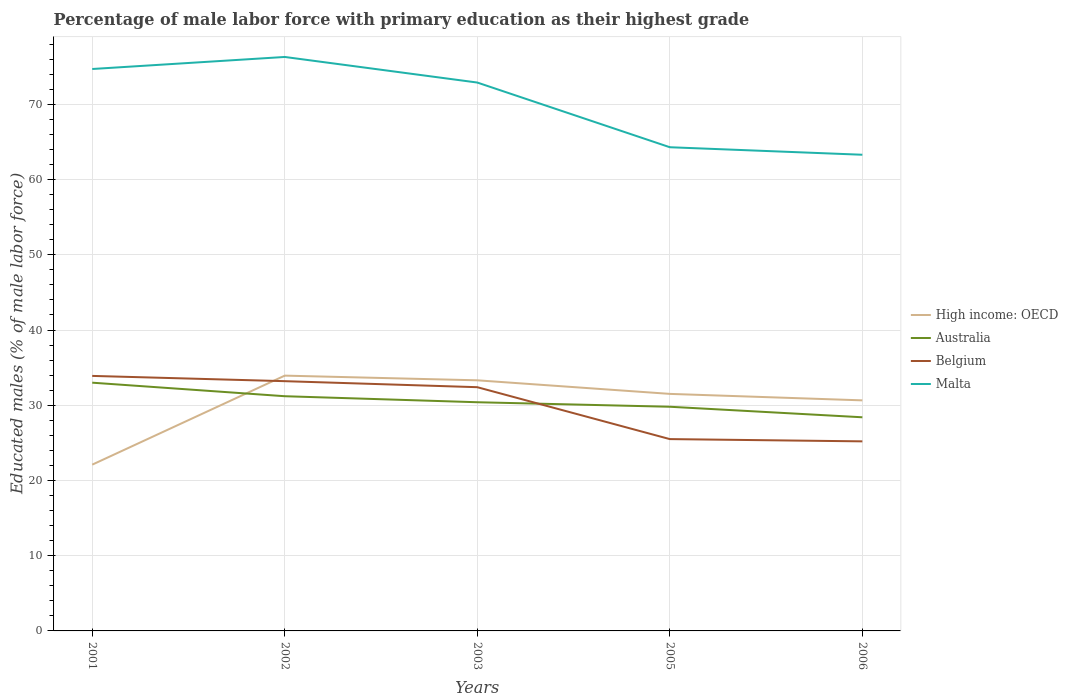Does the line corresponding to Belgium intersect with the line corresponding to Malta?
Offer a very short reply. No. Is the number of lines equal to the number of legend labels?
Make the answer very short. Yes. Across all years, what is the maximum percentage of male labor force with primary education in High income: OECD?
Keep it short and to the point. 22.1. In which year was the percentage of male labor force with primary education in High income: OECD maximum?
Make the answer very short. 2001. What is the difference between the highest and the second highest percentage of male labor force with primary education in Belgium?
Your answer should be compact. 8.7. Is the percentage of male labor force with primary education in High income: OECD strictly greater than the percentage of male labor force with primary education in Belgium over the years?
Offer a very short reply. No. Does the graph contain grids?
Make the answer very short. Yes. How are the legend labels stacked?
Your answer should be very brief. Vertical. What is the title of the graph?
Your answer should be very brief. Percentage of male labor force with primary education as their highest grade. What is the label or title of the Y-axis?
Offer a very short reply. Educated males (% of male labor force). What is the Educated males (% of male labor force) of High income: OECD in 2001?
Give a very brief answer. 22.1. What is the Educated males (% of male labor force) of Belgium in 2001?
Your response must be concise. 33.9. What is the Educated males (% of male labor force) in Malta in 2001?
Give a very brief answer. 74.7. What is the Educated males (% of male labor force) in High income: OECD in 2002?
Make the answer very short. 33.94. What is the Educated males (% of male labor force) in Australia in 2002?
Offer a very short reply. 31.2. What is the Educated males (% of male labor force) in Belgium in 2002?
Provide a short and direct response. 33.2. What is the Educated males (% of male labor force) of Malta in 2002?
Ensure brevity in your answer.  76.3. What is the Educated males (% of male labor force) in High income: OECD in 2003?
Your answer should be very brief. 33.31. What is the Educated males (% of male labor force) in Australia in 2003?
Your answer should be compact. 30.4. What is the Educated males (% of male labor force) of Belgium in 2003?
Your answer should be very brief. 32.4. What is the Educated males (% of male labor force) in Malta in 2003?
Your response must be concise. 72.9. What is the Educated males (% of male labor force) of High income: OECD in 2005?
Keep it short and to the point. 31.51. What is the Educated males (% of male labor force) in Australia in 2005?
Keep it short and to the point. 29.8. What is the Educated males (% of male labor force) of Belgium in 2005?
Keep it short and to the point. 25.5. What is the Educated males (% of male labor force) of Malta in 2005?
Offer a very short reply. 64.3. What is the Educated males (% of male labor force) of High income: OECD in 2006?
Provide a succinct answer. 30.65. What is the Educated males (% of male labor force) in Australia in 2006?
Keep it short and to the point. 28.4. What is the Educated males (% of male labor force) in Belgium in 2006?
Keep it short and to the point. 25.2. What is the Educated males (% of male labor force) of Malta in 2006?
Offer a terse response. 63.3. Across all years, what is the maximum Educated males (% of male labor force) in High income: OECD?
Ensure brevity in your answer.  33.94. Across all years, what is the maximum Educated males (% of male labor force) of Australia?
Give a very brief answer. 33. Across all years, what is the maximum Educated males (% of male labor force) in Belgium?
Your answer should be compact. 33.9. Across all years, what is the maximum Educated males (% of male labor force) in Malta?
Give a very brief answer. 76.3. Across all years, what is the minimum Educated males (% of male labor force) in High income: OECD?
Keep it short and to the point. 22.1. Across all years, what is the minimum Educated males (% of male labor force) of Australia?
Offer a very short reply. 28.4. Across all years, what is the minimum Educated males (% of male labor force) in Belgium?
Offer a terse response. 25.2. Across all years, what is the minimum Educated males (% of male labor force) in Malta?
Ensure brevity in your answer.  63.3. What is the total Educated males (% of male labor force) of High income: OECD in the graph?
Make the answer very short. 151.52. What is the total Educated males (% of male labor force) of Australia in the graph?
Give a very brief answer. 152.8. What is the total Educated males (% of male labor force) in Belgium in the graph?
Provide a short and direct response. 150.2. What is the total Educated males (% of male labor force) in Malta in the graph?
Your response must be concise. 351.5. What is the difference between the Educated males (% of male labor force) of High income: OECD in 2001 and that in 2002?
Offer a very short reply. -11.83. What is the difference between the Educated males (% of male labor force) of Australia in 2001 and that in 2002?
Your answer should be compact. 1.8. What is the difference between the Educated males (% of male labor force) in Malta in 2001 and that in 2002?
Make the answer very short. -1.6. What is the difference between the Educated males (% of male labor force) of High income: OECD in 2001 and that in 2003?
Ensure brevity in your answer.  -11.21. What is the difference between the Educated males (% of male labor force) of Australia in 2001 and that in 2003?
Provide a short and direct response. 2.6. What is the difference between the Educated males (% of male labor force) of High income: OECD in 2001 and that in 2005?
Make the answer very short. -9.41. What is the difference between the Educated males (% of male labor force) of Australia in 2001 and that in 2005?
Your answer should be compact. 3.2. What is the difference between the Educated males (% of male labor force) in High income: OECD in 2001 and that in 2006?
Give a very brief answer. -8.55. What is the difference between the Educated males (% of male labor force) of Australia in 2001 and that in 2006?
Your answer should be compact. 4.6. What is the difference between the Educated males (% of male labor force) in Belgium in 2001 and that in 2006?
Ensure brevity in your answer.  8.7. What is the difference between the Educated males (% of male labor force) in High income: OECD in 2002 and that in 2003?
Your answer should be compact. 0.62. What is the difference between the Educated males (% of male labor force) of High income: OECD in 2002 and that in 2005?
Offer a terse response. 2.43. What is the difference between the Educated males (% of male labor force) of Australia in 2002 and that in 2005?
Provide a succinct answer. 1.4. What is the difference between the Educated males (% of male labor force) in Malta in 2002 and that in 2005?
Offer a very short reply. 12. What is the difference between the Educated males (% of male labor force) of High income: OECD in 2002 and that in 2006?
Give a very brief answer. 3.29. What is the difference between the Educated males (% of male labor force) in Malta in 2002 and that in 2006?
Keep it short and to the point. 13. What is the difference between the Educated males (% of male labor force) of High income: OECD in 2003 and that in 2005?
Ensure brevity in your answer.  1.8. What is the difference between the Educated males (% of male labor force) in Australia in 2003 and that in 2005?
Your answer should be very brief. 0.6. What is the difference between the Educated males (% of male labor force) in Belgium in 2003 and that in 2005?
Provide a succinct answer. 6.9. What is the difference between the Educated males (% of male labor force) of Malta in 2003 and that in 2005?
Provide a succinct answer. 8.6. What is the difference between the Educated males (% of male labor force) of High income: OECD in 2003 and that in 2006?
Provide a short and direct response. 2.66. What is the difference between the Educated males (% of male labor force) in Australia in 2003 and that in 2006?
Provide a short and direct response. 2. What is the difference between the Educated males (% of male labor force) of Malta in 2003 and that in 2006?
Make the answer very short. 9.6. What is the difference between the Educated males (% of male labor force) of High income: OECD in 2005 and that in 2006?
Your response must be concise. 0.86. What is the difference between the Educated males (% of male labor force) in Belgium in 2005 and that in 2006?
Your response must be concise. 0.3. What is the difference between the Educated males (% of male labor force) of High income: OECD in 2001 and the Educated males (% of male labor force) of Australia in 2002?
Provide a short and direct response. -9.1. What is the difference between the Educated males (% of male labor force) of High income: OECD in 2001 and the Educated males (% of male labor force) of Belgium in 2002?
Make the answer very short. -11.1. What is the difference between the Educated males (% of male labor force) of High income: OECD in 2001 and the Educated males (% of male labor force) of Malta in 2002?
Keep it short and to the point. -54.2. What is the difference between the Educated males (% of male labor force) in Australia in 2001 and the Educated males (% of male labor force) in Malta in 2002?
Provide a succinct answer. -43.3. What is the difference between the Educated males (% of male labor force) of Belgium in 2001 and the Educated males (% of male labor force) of Malta in 2002?
Provide a succinct answer. -42.4. What is the difference between the Educated males (% of male labor force) in High income: OECD in 2001 and the Educated males (% of male labor force) in Australia in 2003?
Ensure brevity in your answer.  -8.3. What is the difference between the Educated males (% of male labor force) in High income: OECD in 2001 and the Educated males (% of male labor force) in Belgium in 2003?
Make the answer very short. -10.3. What is the difference between the Educated males (% of male labor force) of High income: OECD in 2001 and the Educated males (% of male labor force) of Malta in 2003?
Make the answer very short. -50.8. What is the difference between the Educated males (% of male labor force) in Australia in 2001 and the Educated males (% of male labor force) in Malta in 2003?
Offer a very short reply. -39.9. What is the difference between the Educated males (% of male labor force) in Belgium in 2001 and the Educated males (% of male labor force) in Malta in 2003?
Keep it short and to the point. -39. What is the difference between the Educated males (% of male labor force) in High income: OECD in 2001 and the Educated males (% of male labor force) in Australia in 2005?
Your answer should be very brief. -7.7. What is the difference between the Educated males (% of male labor force) in High income: OECD in 2001 and the Educated males (% of male labor force) in Belgium in 2005?
Provide a succinct answer. -3.4. What is the difference between the Educated males (% of male labor force) of High income: OECD in 2001 and the Educated males (% of male labor force) of Malta in 2005?
Provide a succinct answer. -42.2. What is the difference between the Educated males (% of male labor force) of Australia in 2001 and the Educated males (% of male labor force) of Belgium in 2005?
Keep it short and to the point. 7.5. What is the difference between the Educated males (% of male labor force) in Australia in 2001 and the Educated males (% of male labor force) in Malta in 2005?
Make the answer very short. -31.3. What is the difference between the Educated males (% of male labor force) in Belgium in 2001 and the Educated males (% of male labor force) in Malta in 2005?
Keep it short and to the point. -30.4. What is the difference between the Educated males (% of male labor force) in High income: OECD in 2001 and the Educated males (% of male labor force) in Australia in 2006?
Provide a succinct answer. -6.3. What is the difference between the Educated males (% of male labor force) of High income: OECD in 2001 and the Educated males (% of male labor force) of Belgium in 2006?
Keep it short and to the point. -3.1. What is the difference between the Educated males (% of male labor force) of High income: OECD in 2001 and the Educated males (% of male labor force) of Malta in 2006?
Your answer should be very brief. -41.2. What is the difference between the Educated males (% of male labor force) of Australia in 2001 and the Educated males (% of male labor force) of Belgium in 2006?
Ensure brevity in your answer.  7.8. What is the difference between the Educated males (% of male labor force) in Australia in 2001 and the Educated males (% of male labor force) in Malta in 2006?
Your response must be concise. -30.3. What is the difference between the Educated males (% of male labor force) of Belgium in 2001 and the Educated males (% of male labor force) of Malta in 2006?
Make the answer very short. -29.4. What is the difference between the Educated males (% of male labor force) of High income: OECD in 2002 and the Educated males (% of male labor force) of Australia in 2003?
Make the answer very short. 3.54. What is the difference between the Educated males (% of male labor force) of High income: OECD in 2002 and the Educated males (% of male labor force) of Belgium in 2003?
Keep it short and to the point. 1.54. What is the difference between the Educated males (% of male labor force) in High income: OECD in 2002 and the Educated males (% of male labor force) in Malta in 2003?
Keep it short and to the point. -38.96. What is the difference between the Educated males (% of male labor force) of Australia in 2002 and the Educated males (% of male labor force) of Belgium in 2003?
Make the answer very short. -1.2. What is the difference between the Educated males (% of male labor force) in Australia in 2002 and the Educated males (% of male labor force) in Malta in 2003?
Your response must be concise. -41.7. What is the difference between the Educated males (% of male labor force) in Belgium in 2002 and the Educated males (% of male labor force) in Malta in 2003?
Your answer should be very brief. -39.7. What is the difference between the Educated males (% of male labor force) of High income: OECD in 2002 and the Educated males (% of male labor force) of Australia in 2005?
Provide a succinct answer. 4.14. What is the difference between the Educated males (% of male labor force) of High income: OECD in 2002 and the Educated males (% of male labor force) of Belgium in 2005?
Your answer should be compact. 8.44. What is the difference between the Educated males (% of male labor force) of High income: OECD in 2002 and the Educated males (% of male labor force) of Malta in 2005?
Your response must be concise. -30.36. What is the difference between the Educated males (% of male labor force) in Australia in 2002 and the Educated males (% of male labor force) in Malta in 2005?
Provide a short and direct response. -33.1. What is the difference between the Educated males (% of male labor force) in Belgium in 2002 and the Educated males (% of male labor force) in Malta in 2005?
Your answer should be very brief. -31.1. What is the difference between the Educated males (% of male labor force) of High income: OECD in 2002 and the Educated males (% of male labor force) of Australia in 2006?
Your response must be concise. 5.54. What is the difference between the Educated males (% of male labor force) in High income: OECD in 2002 and the Educated males (% of male labor force) in Belgium in 2006?
Your response must be concise. 8.74. What is the difference between the Educated males (% of male labor force) of High income: OECD in 2002 and the Educated males (% of male labor force) of Malta in 2006?
Make the answer very short. -29.36. What is the difference between the Educated males (% of male labor force) of Australia in 2002 and the Educated males (% of male labor force) of Malta in 2006?
Provide a short and direct response. -32.1. What is the difference between the Educated males (% of male labor force) of Belgium in 2002 and the Educated males (% of male labor force) of Malta in 2006?
Offer a terse response. -30.1. What is the difference between the Educated males (% of male labor force) of High income: OECD in 2003 and the Educated males (% of male labor force) of Australia in 2005?
Your answer should be compact. 3.51. What is the difference between the Educated males (% of male labor force) of High income: OECD in 2003 and the Educated males (% of male labor force) of Belgium in 2005?
Your answer should be very brief. 7.81. What is the difference between the Educated males (% of male labor force) in High income: OECD in 2003 and the Educated males (% of male labor force) in Malta in 2005?
Provide a succinct answer. -30.99. What is the difference between the Educated males (% of male labor force) in Australia in 2003 and the Educated males (% of male labor force) in Malta in 2005?
Give a very brief answer. -33.9. What is the difference between the Educated males (% of male labor force) in Belgium in 2003 and the Educated males (% of male labor force) in Malta in 2005?
Ensure brevity in your answer.  -31.9. What is the difference between the Educated males (% of male labor force) of High income: OECD in 2003 and the Educated males (% of male labor force) of Australia in 2006?
Keep it short and to the point. 4.91. What is the difference between the Educated males (% of male labor force) in High income: OECD in 2003 and the Educated males (% of male labor force) in Belgium in 2006?
Offer a very short reply. 8.11. What is the difference between the Educated males (% of male labor force) of High income: OECD in 2003 and the Educated males (% of male labor force) of Malta in 2006?
Provide a succinct answer. -29.99. What is the difference between the Educated males (% of male labor force) in Australia in 2003 and the Educated males (% of male labor force) in Malta in 2006?
Provide a succinct answer. -32.9. What is the difference between the Educated males (% of male labor force) of Belgium in 2003 and the Educated males (% of male labor force) of Malta in 2006?
Ensure brevity in your answer.  -30.9. What is the difference between the Educated males (% of male labor force) of High income: OECD in 2005 and the Educated males (% of male labor force) of Australia in 2006?
Your answer should be compact. 3.11. What is the difference between the Educated males (% of male labor force) in High income: OECD in 2005 and the Educated males (% of male labor force) in Belgium in 2006?
Your answer should be compact. 6.31. What is the difference between the Educated males (% of male labor force) in High income: OECD in 2005 and the Educated males (% of male labor force) in Malta in 2006?
Give a very brief answer. -31.79. What is the difference between the Educated males (% of male labor force) in Australia in 2005 and the Educated males (% of male labor force) in Malta in 2006?
Your response must be concise. -33.5. What is the difference between the Educated males (% of male labor force) in Belgium in 2005 and the Educated males (% of male labor force) in Malta in 2006?
Offer a terse response. -37.8. What is the average Educated males (% of male labor force) of High income: OECD per year?
Provide a short and direct response. 30.3. What is the average Educated males (% of male labor force) of Australia per year?
Offer a terse response. 30.56. What is the average Educated males (% of male labor force) of Belgium per year?
Offer a terse response. 30.04. What is the average Educated males (% of male labor force) of Malta per year?
Your response must be concise. 70.3. In the year 2001, what is the difference between the Educated males (% of male labor force) of High income: OECD and Educated males (% of male labor force) of Australia?
Keep it short and to the point. -10.9. In the year 2001, what is the difference between the Educated males (% of male labor force) in High income: OECD and Educated males (% of male labor force) in Belgium?
Offer a very short reply. -11.8. In the year 2001, what is the difference between the Educated males (% of male labor force) of High income: OECD and Educated males (% of male labor force) of Malta?
Provide a short and direct response. -52.6. In the year 2001, what is the difference between the Educated males (% of male labor force) of Australia and Educated males (% of male labor force) of Belgium?
Offer a terse response. -0.9. In the year 2001, what is the difference between the Educated males (% of male labor force) in Australia and Educated males (% of male labor force) in Malta?
Offer a terse response. -41.7. In the year 2001, what is the difference between the Educated males (% of male labor force) of Belgium and Educated males (% of male labor force) of Malta?
Keep it short and to the point. -40.8. In the year 2002, what is the difference between the Educated males (% of male labor force) in High income: OECD and Educated males (% of male labor force) in Australia?
Your response must be concise. 2.74. In the year 2002, what is the difference between the Educated males (% of male labor force) of High income: OECD and Educated males (% of male labor force) of Belgium?
Give a very brief answer. 0.74. In the year 2002, what is the difference between the Educated males (% of male labor force) in High income: OECD and Educated males (% of male labor force) in Malta?
Offer a terse response. -42.36. In the year 2002, what is the difference between the Educated males (% of male labor force) of Australia and Educated males (% of male labor force) of Malta?
Offer a terse response. -45.1. In the year 2002, what is the difference between the Educated males (% of male labor force) in Belgium and Educated males (% of male labor force) in Malta?
Your response must be concise. -43.1. In the year 2003, what is the difference between the Educated males (% of male labor force) in High income: OECD and Educated males (% of male labor force) in Australia?
Make the answer very short. 2.91. In the year 2003, what is the difference between the Educated males (% of male labor force) in High income: OECD and Educated males (% of male labor force) in Belgium?
Provide a short and direct response. 0.91. In the year 2003, what is the difference between the Educated males (% of male labor force) in High income: OECD and Educated males (% of male labor force) in Malta?
Your answer should be very brief. -39.59. In the year 2003, what is the difference between the Educated males (% of male labor force) of Australia and Educated males (% of male labor force) of Malta?
Provide a short and direct response. -42.5. In the year 2003, what is the difference between the Educated males (% of male labor force) in Belgium and Educated males (% of male labor force) in Malta?
Your answer should be compact. -40.5. In the year 2005, what is the difference between the Educated males (% of male labor force) in High income: OECD and Educated males (% of male labor force) in Australia?
Your answer should be compact. 1.71. In the year 2005, what is the difference between the Educated males (% of male labor force) of High income: OECD and Educated males (% of male labor force) of Belgium?
Offer a very short reply. 6.01. In the year 2005, what is the difference between the Educated males (% of male labor force) in High income: OECD and Educated males (% of male labor force) in Malta?
Your response must be concise. -32.79. In the year 2005, what is the difference between the Educated males (% of male labor force) in Australia and Educated males (% of male labor force) in Belgium?
Your answer should be very brief. 4.3. In the year 2005, what is the difference between the Educated males (% of male labor force) of Australia and Educated males (% of male labor force) of Malta?
Keep it short and to the point. -34.5. In the year 2005, what is the difference between the Educated males (% of male labor force) in Belgium and Educated males (% of male labor force) in Malta?
Ensure brevity in your answer.  -38.8. In the year 2006, what is the difference between the Educated males (% of male labor force) of High income: OECD and Educated males (% of male labor force) of Australia?
Offer a terse response. 2.25. In the year 2006, what is the difference between the Educated males (% of male labor force) in High income: OECD and Educated males (% of male labor force) in Belgium?
Offer a very short reply. 5.45. In the year 2006, what is the difference between the Educated males (% of male labor force) in High income: OECD and Educated males (% of male labor force) in Malta?
Offer a terse response. -32.65. In the year 2006, what is the difference between the Educated males (% of male labor force) in Australia and Educated males (% of male labor force) in Malta?
Your answer should be very brief. -34.9. In the year 2006, what is the difference between the Educated males (% of male labor force) in Belgium and Educated males (% of male labor force) in Malta?
Provide a short and direct response. -38.1. What is the ratio of the Educated males (% of male labor force) of High income: OECD in 2001 to that in 2002?
Provide a succinct answer. 0.65. What is the ratio of the Educated males (% of male labor force) of Australia in 2001 to that in 2002?
Your answer should be very brief. 1.06. What is the ratio of the Educated males (% of male labor force) in Belgium in 2001 to that in 2002?
Keep it short and to the point. 1.02. What is the ratio of the Educated males (% of male labor force) in Malta in 2001 to that in 2002?
Your response must be concise. 0.98. What is the ratio of the Educated males (% of male labor force) in High income: OECD in 2001 to that in 2003?
Provide a short and direct response. 0.66. What is the ratio of the Educated males (% of male labor force) in Australia in 2001 to that in 2003?
Offer a terse response. 1.09. What is the ratio of the Educated males (% of male labor force) in Belgium in 2001 to that in 2003?
Give a very brief answer. 1.05. What is the ratio of the Educated males (% of male labor force) of Malta in 2001 to that in 2003?
Give a very brief answer. 1.02. What is the ratio of the Educated males (% of male labor force) of High income: OECD in 2001 to that in 2005?
Give a very brief answer. 0.7. What is the ratio of the Educated males (% of male labor force) in Australia in 2001 to that in 2005?
Provide a short and direct response. 1.11. What is the ratio of the Educated males (% of male labor force) of Belgium in 2001 to that in 2005?
Keep it short and to the point. 1.33. What is the ratio of the Educated males (% of male labor force) of Malta in 2001 to that in 2005?
Ensure brevity in your answer.  1.16. What is the ratio of the Educated males (% of male labor force) of High income: OECD in 2001 to that in 2006?
Your answer should be very brief. 0.72. What is the ratio of the Educated males (% of male labor force) in Australia in 2001 to that in 2006?
Your answer should be very brief. 1.16. What is the ratio of the Educated males (% of male labor force) of Belgium in 2001 to that in 2006?
Your answer should be very brief. 1.35. What is the ratio of the Educated males (% of male labor force) of Malta in 2001 to that in 2006?
Keep it short and to the point. 1.18. What is the ratio of the Educated males (% of male labor force) in High income: OECD in 2002 to that in 2003?
Keep it short and to the point. 1.02. What is the ratio of the Educated males (% of male labor force) in Australia in 2002 to that in 2003?
Give a very brief answer. 1.03. What is the ratio of the Educated males (% of male labor force) of Belgium in 2002 to that in 2003?
Offer a terse response. 1.02. What is the ratio of the Educated males (% of male labor force) in Malta in 2002 to that in 2003?
Your answer should be compact. 1.05. What is the ratio of the Educated males (% of male labor force) in High income: OECD in 2002 to that in 2005?
Keep it short and to the point. 1.08. What is the ratio of the Educated males (% of male labor force) of Australia in 2002 to that in 2005?
Your response must be concise. 1.05. What is the ratio of the Educated males (% of male labor force) in Belgium in 2002 to that in 2005?
Give a very brief answer. 1.3. What is the ratio of the Educated males (% of male labor force) of Malta in 2002 to that in 2005?
Your response must be concise. 1.19. What is the ratio of the Educated males (% of male labor force) in High income: OECD in 2002 to that in 2006?
Offer a very short reply. 1.11. What is the ratio of the Educated males (% of male labor force) of Australia in 2002 to that in 2006?
Ensure brevity in your answer.  1.1. What is the ratio of the Educated males (% of male labor force) of Belgium in 2002 to that in 2006?
Your response must be concise. 1.32. What is the ratio of the Educated males (% of male labor force) of Malta in 2002 to that in 2006?
Give a very brief answer. 1.21. What is the ratio of the Educated males (% of male labor force) in High income: OECD in 2003 to that in 2005?
Offer a very short reply. 1.06. What is the ratio of the Educated males (% of male labor force) in Australia in 2003 to that in 2005?
Keep it short and to the point. 1.02. What is the ratio of the Educated males (% of male labor force) of Belgium in 2003 to that in 2005?
Your response must be concise. 1.27. What is the ratio of the Educated males (% of male labor force) of Malta in 2003 to that in 2005?
Offer a terse response. 1.13. What is the ratio of the Educated males (% of male labor force) of High income: OECD in 2003 to that in 2006?
Your answer should be very brief. 1.09. What is the ratio of the Educated males (% of male labor force) of Australia in 2003 to that in 2006?
Keep it short and to the point. 1.07. What is the ratio of the Educated males (% of male labor force) in Malta in 2003 to that in 2006?
Your response must be concise. 1.15. What is the ratio of the Educated males (% of male labor force) in High income: OECD in 2005 to that in 2006?
Offer a very short reply. 1.03. What is the ratio of the Educated males (% of male labor force) of Australia in 2005 to that in 2006?
Ensure brevity in your answer.  1.05. What is the ratio of the Educated males (% of male labor force) of Belgium in 2005 to that in 2006?
Provide a succinct answer. 1.01. What is the ratio of the Educated males (% of male labor force) of Malta in 2005 to that in 2006?
Offer a terse response. 1.02. What is the difference between the highest and the second highest Educated males (% of male labor force) of High income: OECD?
Provide a succinct answer. 0.62. What is the difference between the highest and the second highest Educated males (% of male labor force) in Australia?
Provide a short and direct response. 1.8. What is the difference between the highest and the second highest Educated males (% of male labor force) of Belgium?
Give a very brief answer. 0.7. What is the difference between the highest and the second highest Educated males (% of male labor force) in Malta?
Your response must be concise. 1.6. What is the difference between the highest and the lowest Educated males (% of male labor force) of High income: OECD?
Ensure brevity in your answer.  11.83. What is the difference between the highest and the lowest Educated males (% of male labor force) in Australia?
Provide a short and direct response. 4.6. What is the difference between the highest and the lowest Educated males (% of male labor force) of Malta?
Offer a terse response. 13. 